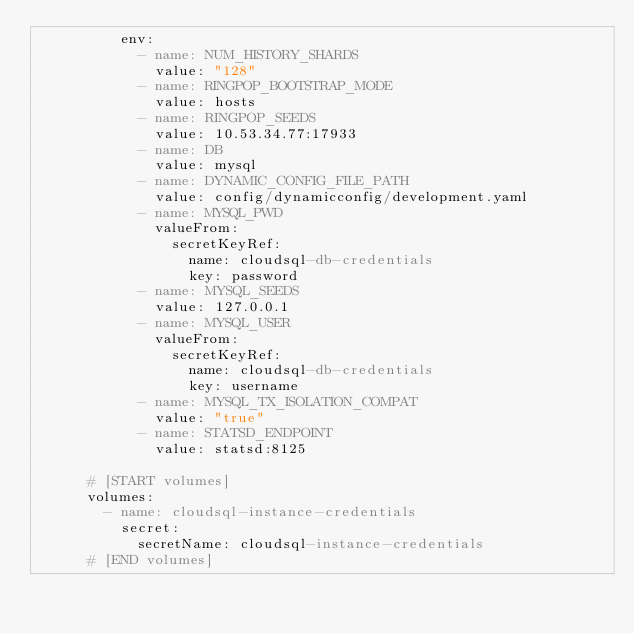<code> <loc_0><loc_0><loc_500><loc_500><_YAML_>          env:
            - name: NUM_HISTORY_SHARDS
              value: "128"
            - name: RINGPOP_BOOTSTRAP_MODE
              value: hosts
            - name: RINGPOP_SEEDS
              value: 10.53.34.77:17933
            - name: DB
              value: mysql
            - name: DYNAMIC_CONFIG_FILE_PATH
              value: config/dynamicconfig/development.yaml
            - name: MYSQL_PWD
              valueFrom:
                secretKeyRef:
                  name: cloudsql-db-credentials
                  key: password
            - name: MYSQL_SEEDS
              value: 127.0.0.1
            - name: MYSQL_USER
              valueFrom:
                secretKeyRef:
                  name: cloudsql-db-credentials
                  key: username
            - name: MYSQL_TX_ISOLATION_COMPAT
              value: "true"
            - name: STATSD_ENDPOINT
              value: statsd:8125

      # [START volumes]
      volumes:
        - name: cloudsql-instance-credentials
          secret:
            secretName: cloudsql-instance-credentials
      # [END volumes]
</code> 